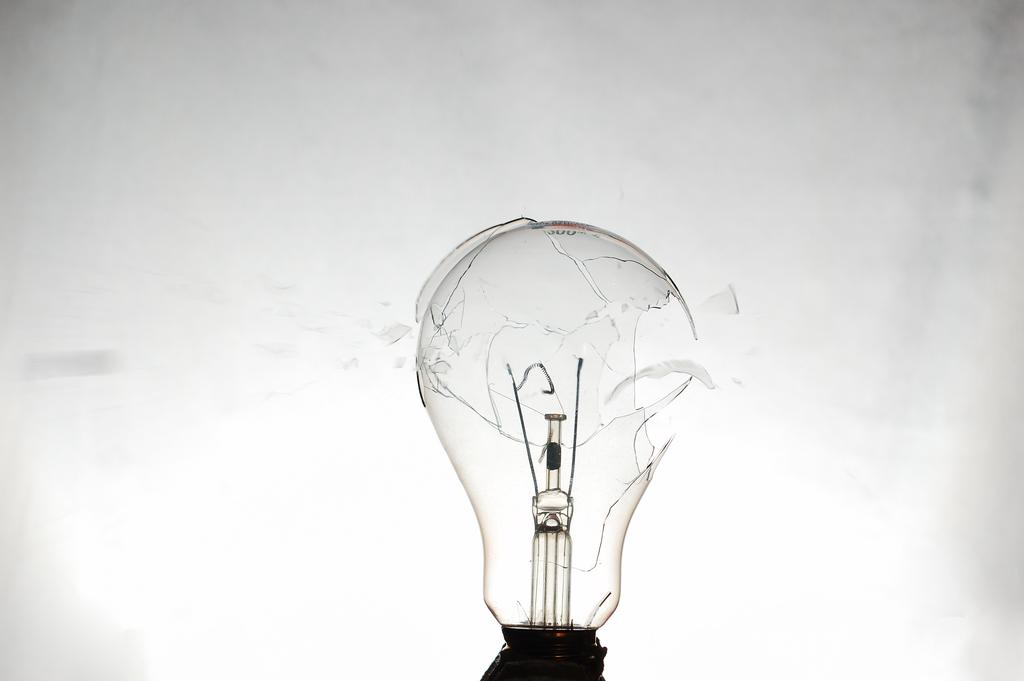What is the main subject of the picture? The main subject of the picture is a broken bulb. What type of rifle can be seen in the image? There is no rifle present in the image; it features a broken bulb. 